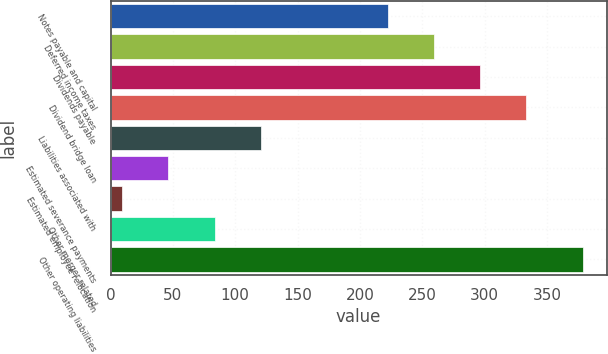<chart> <loc_0><loc_0><loc_500><loc_500><bar_chart><fcel>Notes payable and capital<fcel>Deferred income taxes<fcel>Dividends payable<fcel>Dividend bridge loan<fcel>Liabilities associated with<fcel>Estimated severance payments<fcel>Estimated employee relocation<fcel>Other merger related<fcel>Other operating liabilities<nl><fcel>222.8<fcel>259.76<fcel>296.72<fcel>333.68<fcel>120.38<fcel>46.46<fcel>9.5<fcel>83.42<fcel>379.1<nl></chart> 